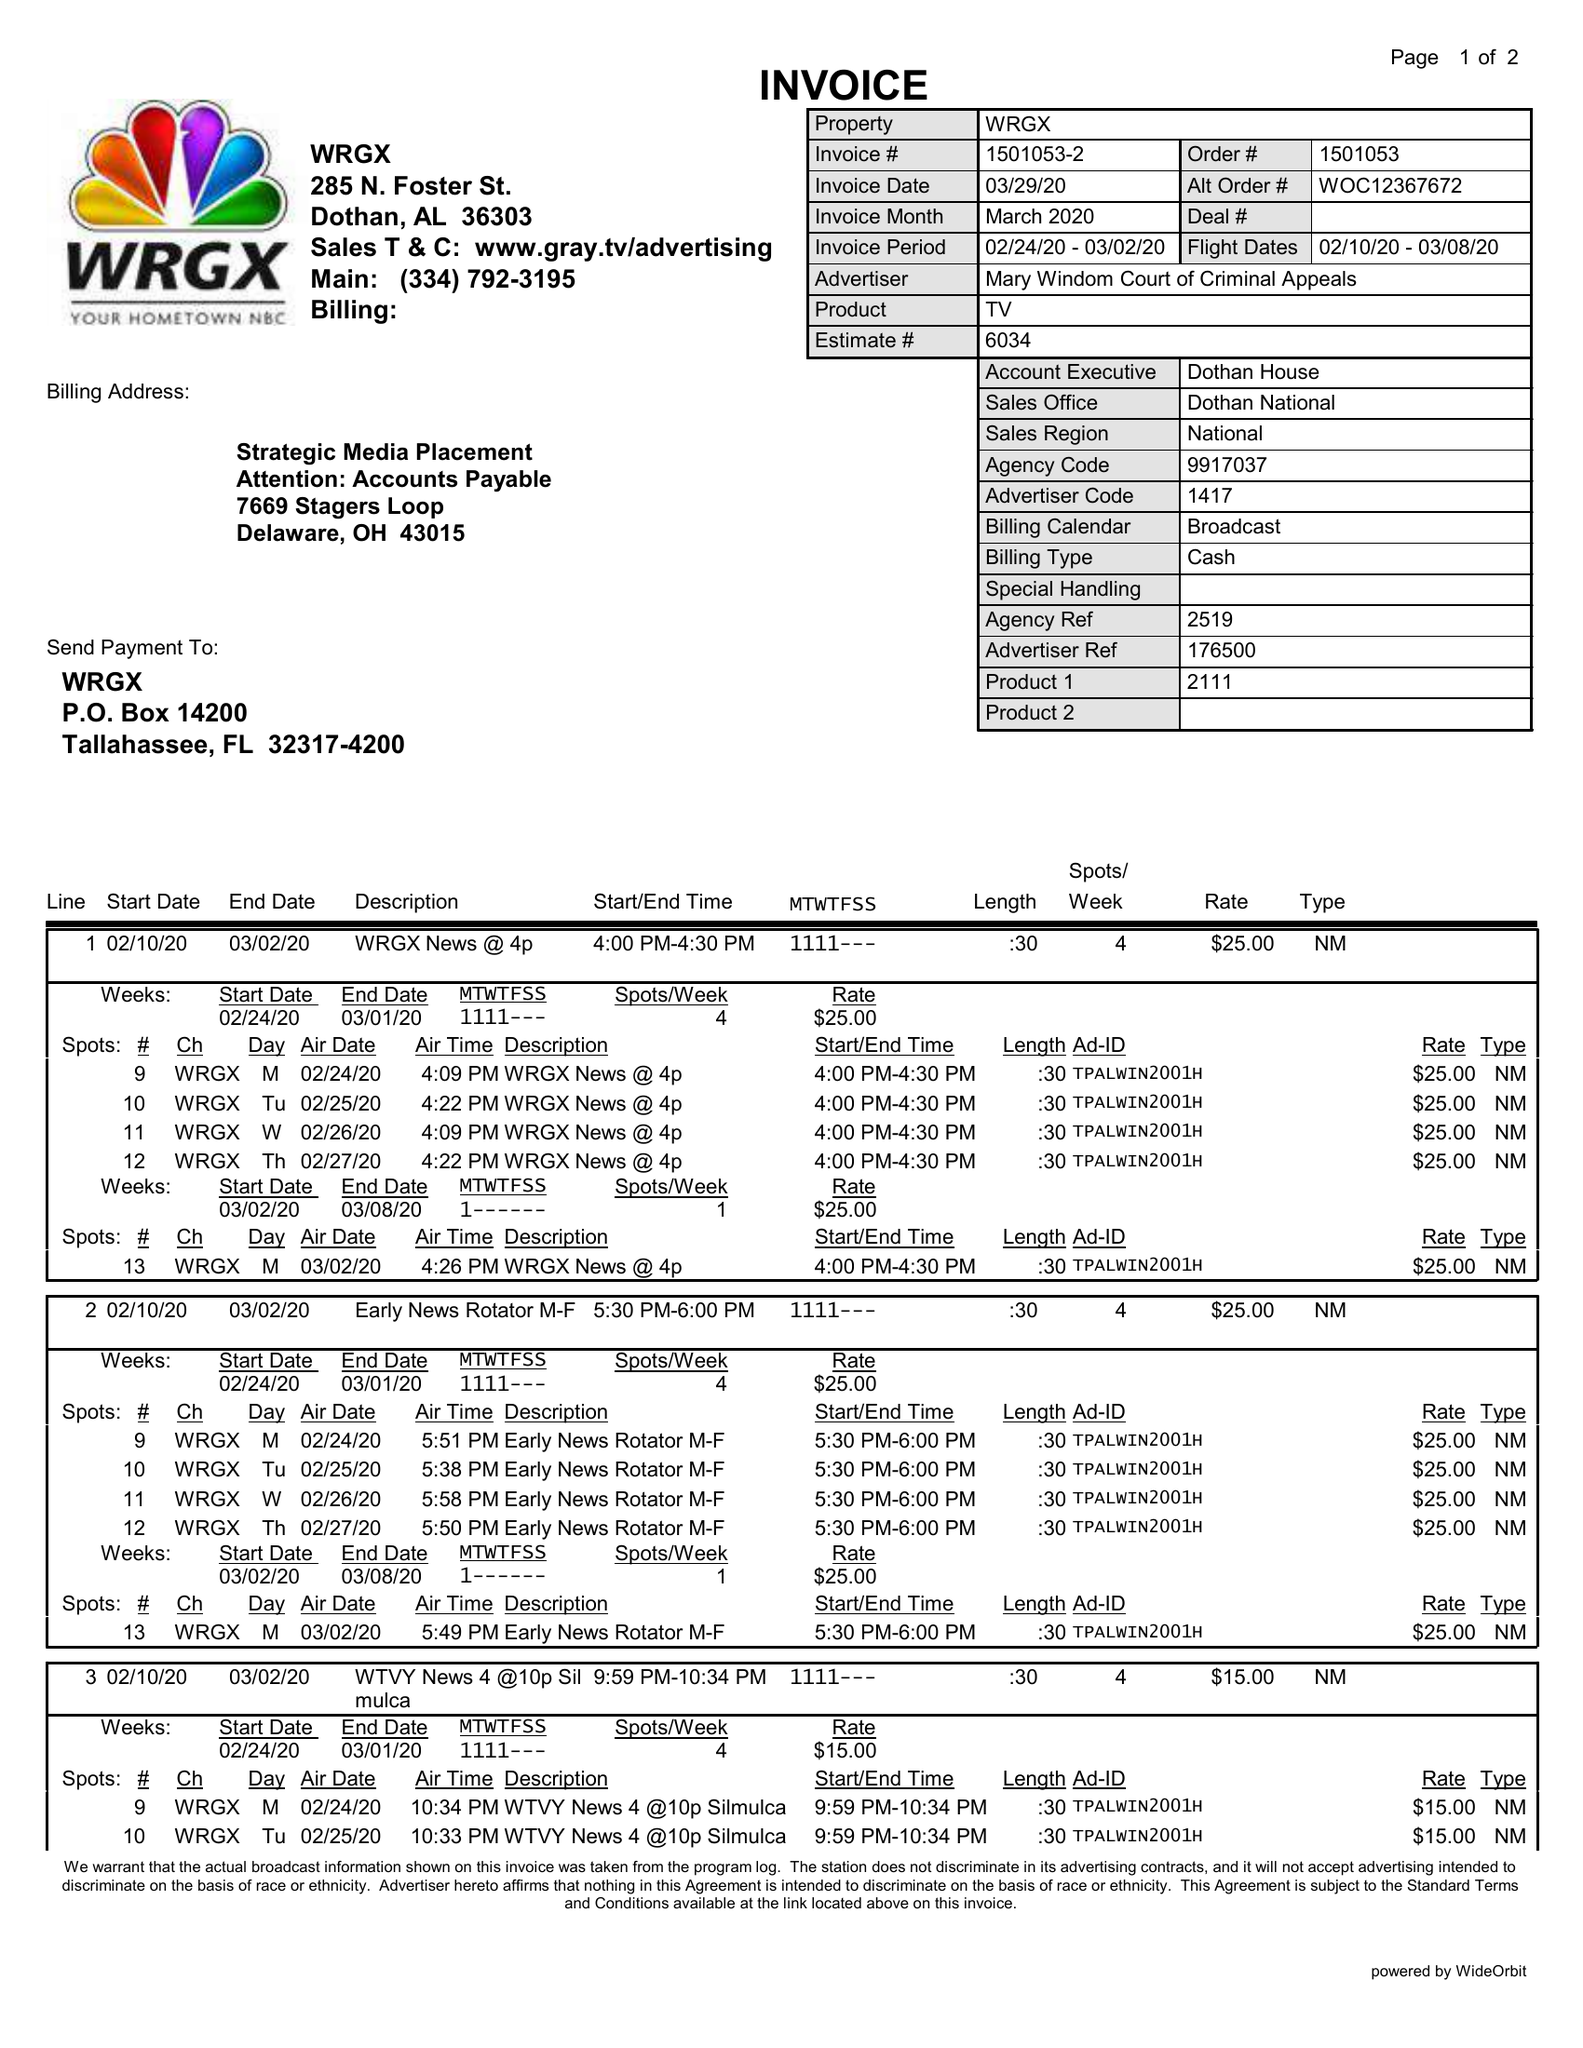What is the value for the gross_amount?
Answer the question using a single word or phrase. 325.00 